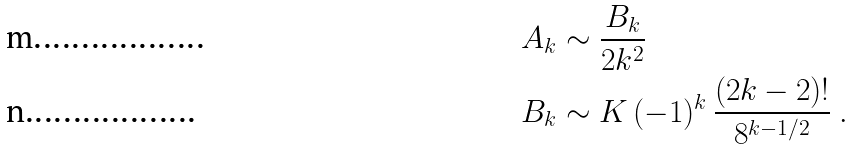<formula> <loc_0><loc_0><loc_500><loc_500>A _ { k } & \sim \frac { B _ { k } } { 2 k ^ { 2 } } \\ B _ { k } & \sim K \, ( - 1 ) ^ { k } \, \frac { ( 2 k - 2 ) ! } { 8 ^ { k - 1 / 2 } } \ .</formula> 